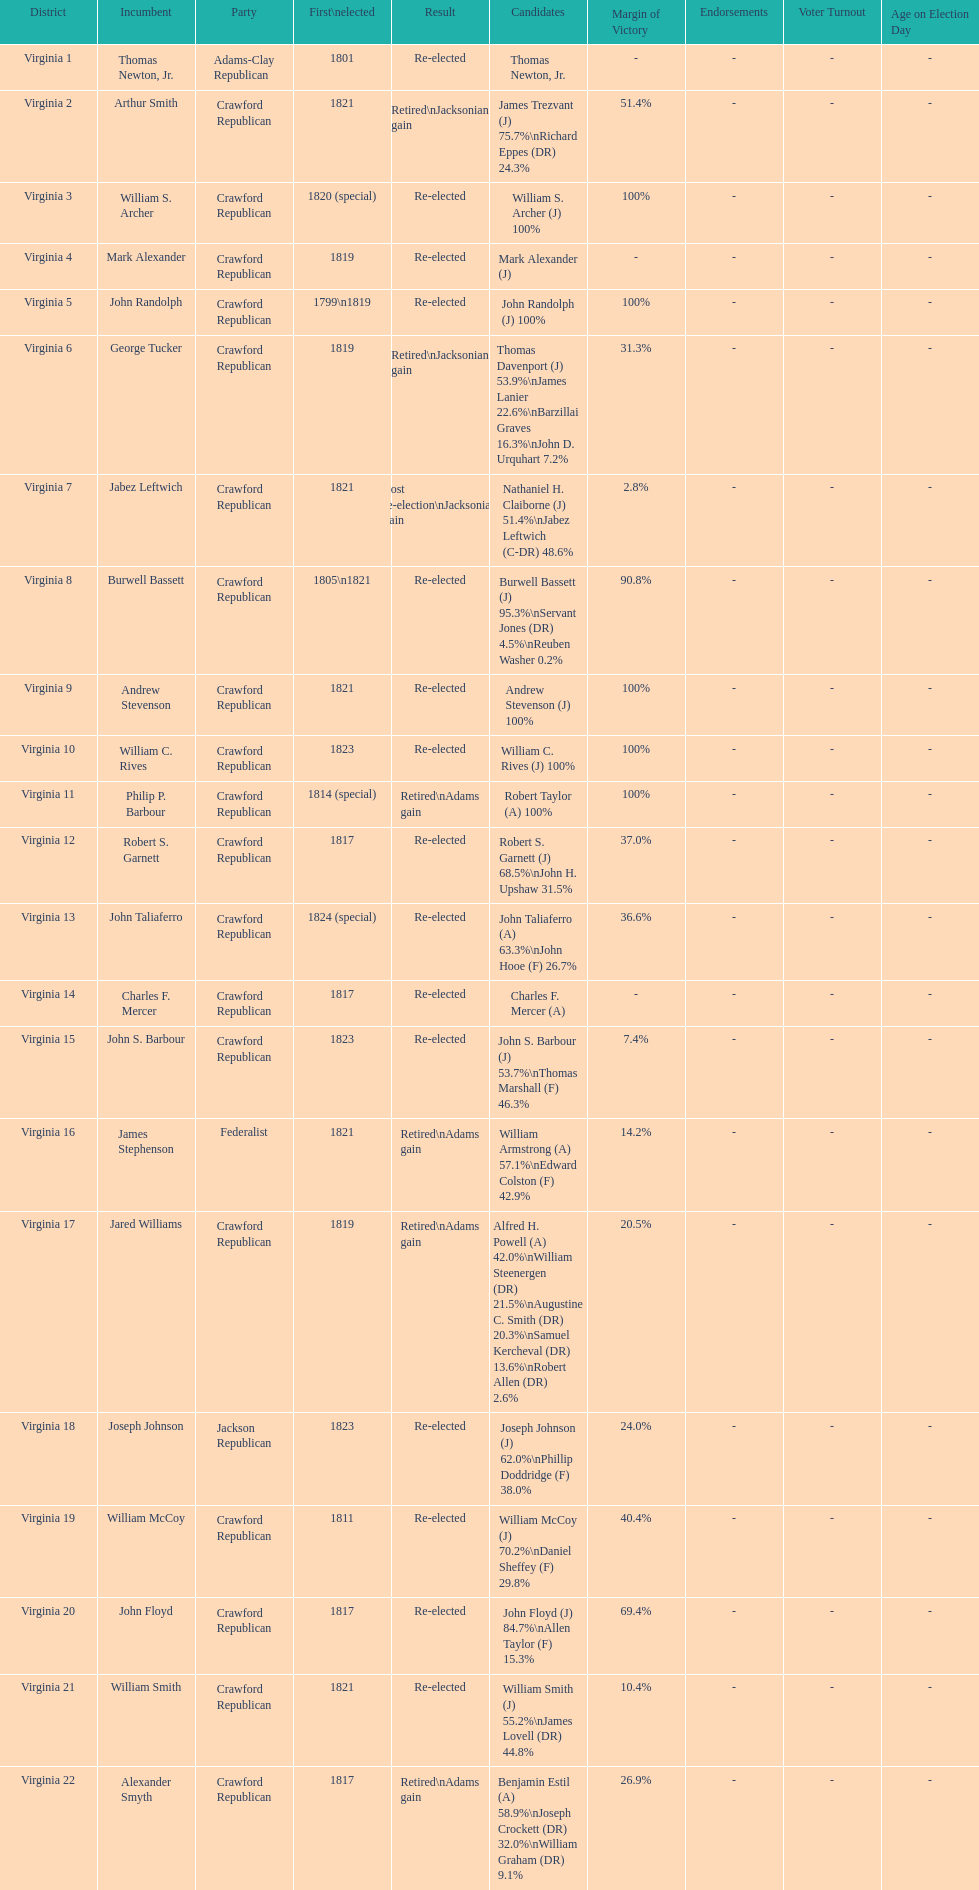Can you parse all the data within this table? {'header': ['District', 'Incumbent', 'Party', 'First\\nelected', 'Result', 'Candidates', 'Margin of Victory', 'Endorsements', 'Voter Turnout', 'Age on Election Day'], 'rows': [['Virginia 1', 'Thomas Newton, Jr.', 'Adams-Clay Republican', '1801', 'Re-elected', 'Thomas Newton, Jr.', '-', '-', '-', '-'], ['Virginia 2', 'Arthur Smith', 'Crawford Republican', '1821', 'Retired\\nJacksonian gain', 'James Trezvant (J) 75.7%\\nRichard Eppes (DR) 24.3%', '51.4%', '-', '-', '-'], ['Virginia 3', 'William S. Archer', 'Crawford Republican', '1820 (special)', 'Re-elected', 'William S. Archer (J) 100%', '100%', '-', '-', '-'], ['Virginia 4', 'Mark Alexander', 'Crawford Republican', '1819', 'Re-elected', 'Mark Alexander (J)', '-', '-', '-', '-'], ['Virginia 5', 'John Randolph', 'Crawford Republican', '1799\\n1819', 'Re-elected', 'John Randolph (J) 100%', '100%', '-', '-', '-'], ['Virginia 6', 'George Tucker', 'Crawford Republican', '1819', 'Retired\\nJacksonian gain', 'Thomas Davenport (J) 53.9%\\nJames Lanier 22.6%\\nBarzillai Graves 16.3%\\nJohn D. Urquhart 7.2%', '31.3%', '-', '-', '-'], ['Virginia 7', 'Jabez Leftwich', 'Crawford Republican', '1821', 'Lost re-election\\nJacksonian gain', 'Nathaniel H. Claiborne (J) 51.4%\\nJabez Leftwich (C-DR) 48.6%', '2.8%', '-', '-', '-'], ['Virginia 8', 'Burwell Bassett', 'Crawford Republican', '1805\\n1821', 'Re-elected', 'Burwell Bassett (J) 95.3%\\nServant Jones (DR) 4.5%\\nReuben Washer 0.2%', '90.8%', '-', '-', '-'], ['Virginia 9', 'Andrew Stevenson', 'Crawford Republican', '1821', 'Re-elected', 'Andrew Stevenson (J) 100%', '100%', '-', '-', '-'], ['Virginia 10', 'William C. Rives', 'Crawford Republican', '1823', 'Re-elected', 'William C. Rives (J) 100%', '100%', '-', '-', '-'], ['Virginia 11', 'Philip P. Barbour', 'Crawford Republican', '1814 (special)', 'Retired\\nAdams gain', 'Robert Taylor (A) 100%', '100%', '-', '-', '-'], ['Virginia 12', 'Robert S. Garnett', 'Crawford Republican', '1817', 'Re-elected', 'Robert S. Garnett (J) 68.5%\\nJohn H. Upshaw 31.5%', '37.0%', '-', '-', '-'], ['Virginia 13', 'John Taliaferro', 'Crawford Republican', '1824 (special)', 'Re-elected', 'John Taliaferro (A) 63.3%\\nJohn Hooe (F) 26.7%', '36.6%', '-', '-', '-'], ['Virginia 14', 'Charles F. Mercer', 'Crawford Republican', '1817', 'Re-elected', 'Charles F. Mercer (A)', '-', '-', '-', '-'], ['Virginia 15', 'John S. Barbour', 'Crawford Republican', '1823', 'Re-elected', 'John S. Barbour (J) 53.7%\\nThomas Marshall (F) 46.3%', '7.4%', '-', '-', '-'], ['Virginia 16', 'James Stephenson', 'Federalist', '1821', 'Retired\\nAdams gain', 'William Armstrong (A) 57.1%\\nEdward Colston (F) 42.9%', '14.2%', '-', '-', '-'], ['Virginia 17', 'Jared Williams', 'Crawford Republican', '1819', 'Retired\\nAdams gain', 'Alfred H. Powell (A) 42.0%\\nWilliam Steenergen (DR) 21.5%\\nAugustine C. Smith (DR) 20.3%\\nSamuel Kercheval (DR) 13.6%\\nRobert Allen (DR) 2.6%', '20.5%', '-', '-', '-'], ['Virginia 18', 'Joseph Johnson', 'Jackson Republican', '1823', 'Re-elected', 'Joseph Johnson (J) 62.0%\\nPhillip Doddridge (F) 38.0%', '24.0%', '-', '-', '-'], ['Virginia 19', 'William McCoy', 'Crawford Republican', '1811', 'Re-elected', 'William McCoy (J) 70.2%\\nDaniel Sheffey (F) 29.8%', '40.4%', '-', '-', '-'], ['Virginia 20', 'John Floyd', 'Crawford Republican', '1817', 'Re-elected', 'John Floyd (J) 84.7%\\nAllen Taylor (F) 15.3%', '69.4%', '-', '-', '-'], ['Virginia 21', 'William Smith', 'Crawford Republican', '1821', 'Re-elected', 'William Smith (J) 55.2%\\nJames Lovell (DR) 44.8%', '10.4%', '-', '-', '-'], ['Virginia 22', 'Alexander Smyth', 'Crawford Republican', '1817', 'Retired\\nAdams gain', 'Benjamin Estil (A) 58.9%\\nJoseph Crockett (DR) 32.0%\\nWilliam Graham (DR) 9.1%', '26.9%', '-', '-', '-']]} How many people were elected for the first time in 1817? 4. 